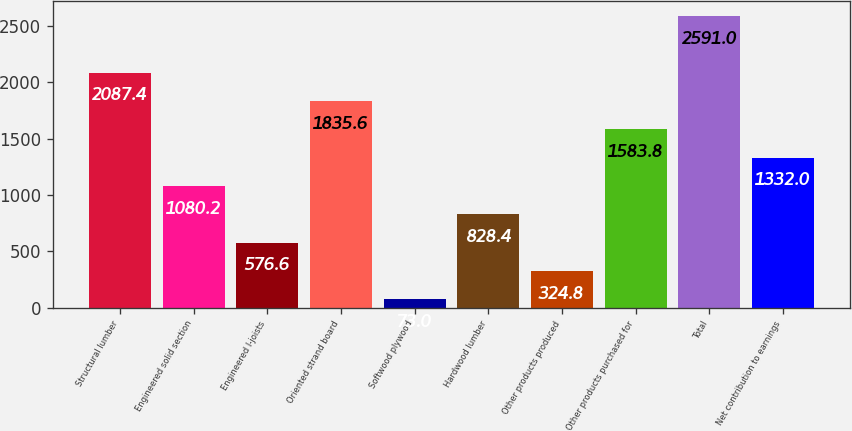Convert chart to OTSL. <chart><loc_0><loc_0><loc_500><loc_500><bar_chart><fcel>Structural lumber<fcel>Engineered solid section<fcel>Engineered I-joists<fcel>Oriented strand board<fcel>Softwood plywood<fcel>Hardwood lumber<fcel>Other products produced<fcel>Other products purchased for<fcel>Total<fcel>Net contribution to earnings<nl><fcel>2087.4<fcel>1080.2<fcel>576.6<fcel>1835.6<fcel>73<fcel>828.4<fcel>324.8<fcel>1583.8<fcel>2591<fcel>1332<nl></chart> 